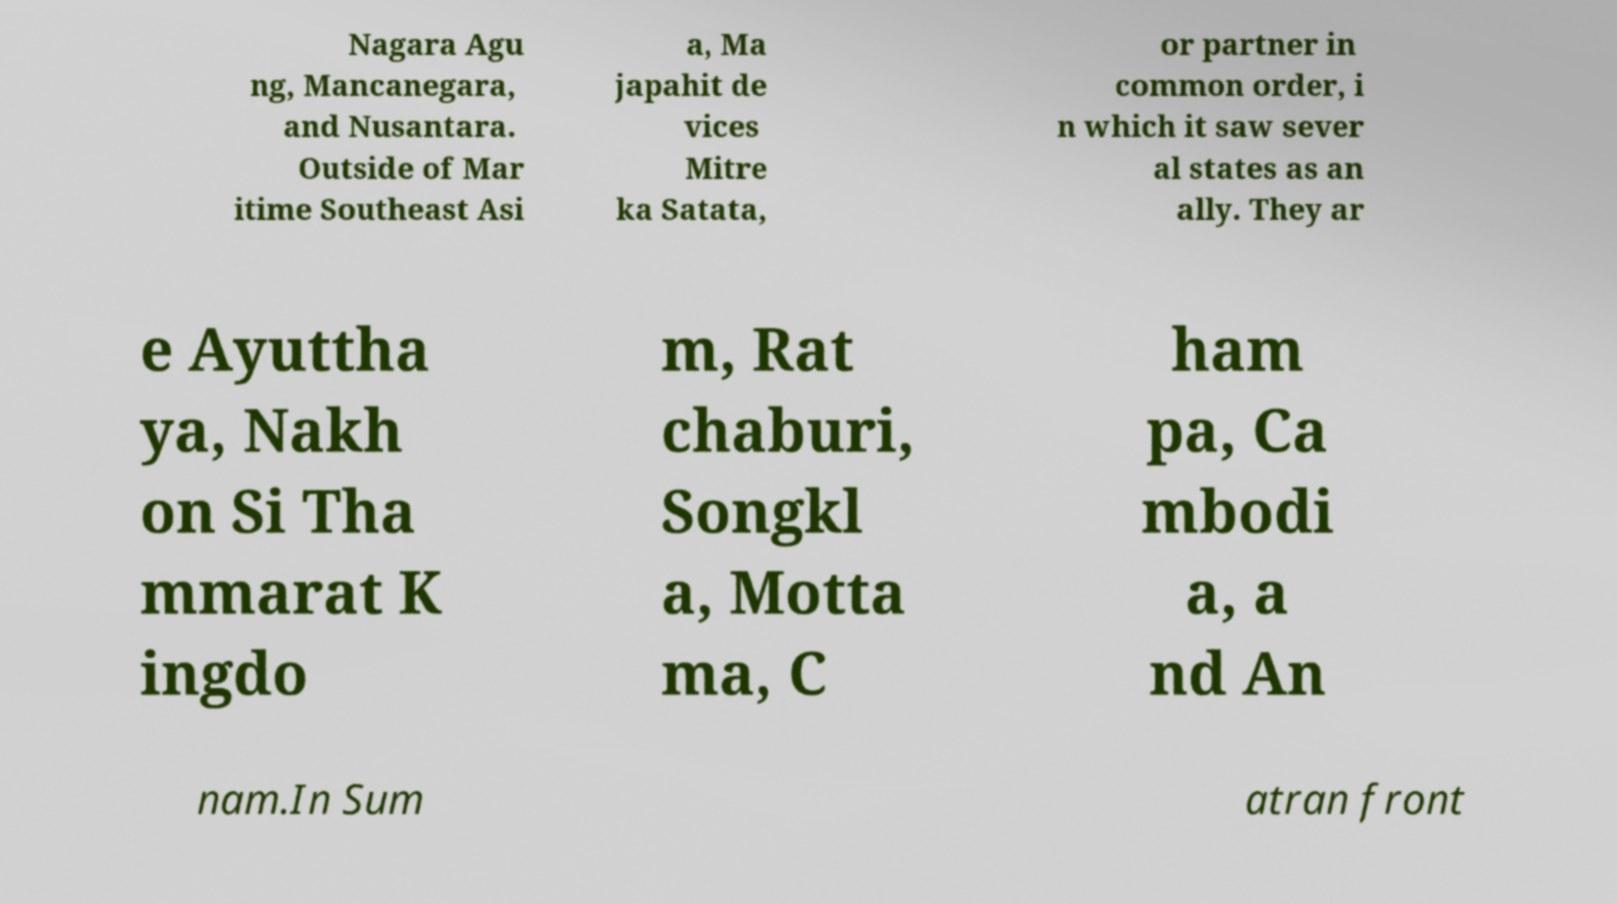For documentation purposes, I need the text within this image transcribed. Could you provide that? Nagara Agu ng, Mancanegara, and Nusantara. Outside of Mar itime Southeast Asi a, Ma japahit de vices Mitre ka Satata, or partner in common order, i n which it saw sever al states as an ally. They ar e Ayuttha ya, Nakh on Si Tha mmarat K ingdo m, Rat chaburi, Songkl a, Motta ma, C ham pa, Ca mbodi a, a nd An nam.In Sum atran front 